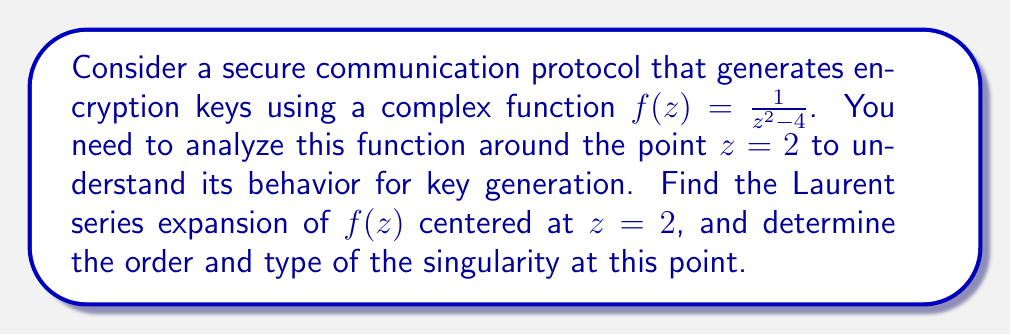Show me your answer to this math problem. To find the Laurent series expansion of $f(z) = \frac{1}{z^2 - 4}$ centered at $z = 2$, we follow these steps:

1) First, we rewrite the function in terms of $(z - 2)$:

   $f(z) = \frac{1}{z^2 - 4} = \frac{1}{(z+2)(z-2)}$

2) We can further simplify this:

   $f(z) = \frac{1}{4(1 + \frac{z-2}{4})(z-2)}$

3) Now, we can use the geometric series expansion:

   $\frac{1}{1+x} = 1 - x + x^2 - x^3 + ...$, for $|x| < 1$

4) In our case, $x = \frac{z-2}{4}$. So we have:

   $f(z) = \frac{1}{4(z-2)} \cdot \frac{1}{1 + \frac{z-2}{4}}$
   
   $= \frac{1}{4(z-2)} \cdot (1 - \frac{z-2}{4} + (\frac{z-2}{4})^2 - (\frac{z-2}{4})^3 + ...)$

5) Multiplying this out:

   $f(z) = \frac{1}{4(z-2)} - \frac{1}{16} + \frac{z-2}{64} - \frac{(z-2)^2}{256} + ...$

This is the Laurent series expansion of $f(z)$ centered at $z = 2$.

To determine the order and type of the singularity:

- The series has a term with $(z-2)^{-1}$, which is the lowest negative power.
- There are no terms with lower powers (like $(z-2)^{-2}$, $(z-2)^{-3}$, etc.)
- The coefficient of $(z-2)^{-1}$ is non-zero ($\frac{1}{4}$).

Therefore, $z = 2$ is a simple pole (order 1) of $f(z)$.
Answer: The Laurent series expansion of $f(z) = \frac{1}{z^2 - 4}$ centered at $z = 2$ is:

$$f(z) = \frac{1}{4(z-2)} - \frac{1}{16} + \frac{z-2}{64} - \frac{(z-2)^2}{256} + ...$$

The function has a simple pole (order 1) at $z = 2$. 